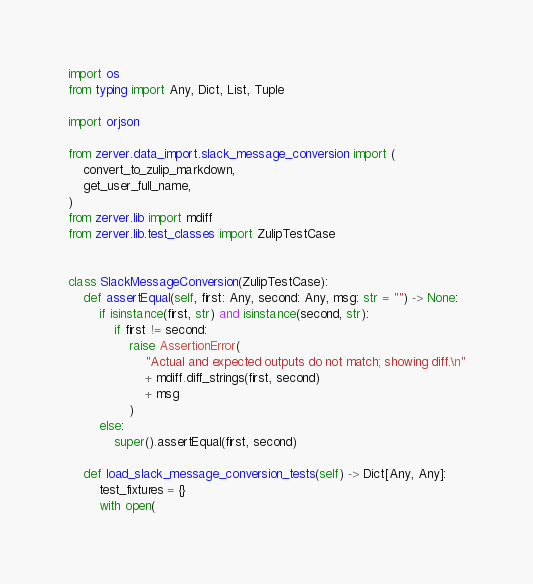<code> <loc_0><loc_0><loc_500><loc_500><_Python_>import os
from typing import Any, Dict, List, Tuple

import orjson

from zerver.data_import.slack_message_conversion import (
    convert_to_zulip_markdown,
    get_user_full_name,
)
from zerver.lib import mdiff
from zerver.lib.test_classes import ZulipTestCase


class SlackMessageConversion(ZulipTestCase):
    def assertEqual(self, first: Any, second: Any, msg: str = "") -> None:
        if isinstance(first, str) and isinstance(second, str):
            if first != second:
                raise AssertionError(
                    "Actual and expected outputs do not match; showing diff.\n"
                    + mdiff.diff_strings(first, second)
                    + msg
                )
        else:
            super().assertEqual(first, second)

    def load_slack_message_conversion_tests(self) -> Dict[Any, Any]:
        test_fixtures = {}
        with open(</code> 